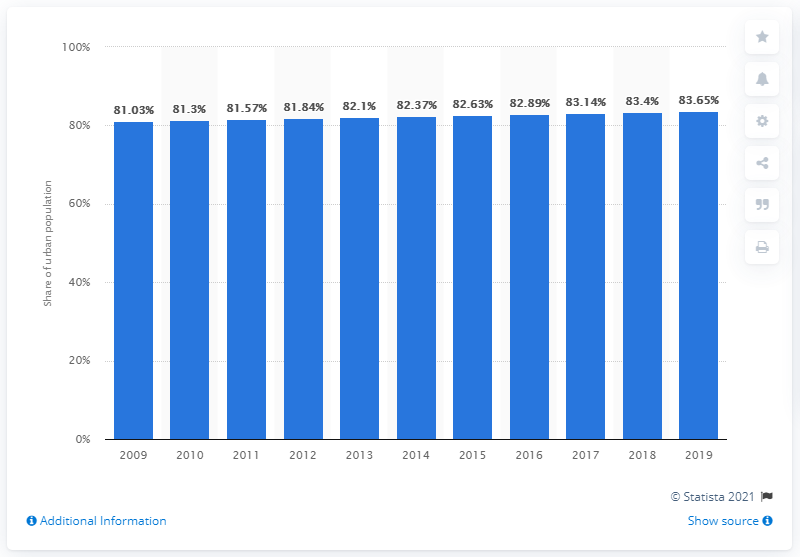Indicate a few pertinent items in this graphic. In 2019, the urbanization rate in the UK was 83.65%. The amount of urbanization in the UK has increased significantly over the past decade, with a decimal value of 83.65. 